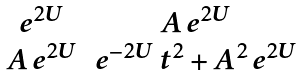<formula> <loc_0><loc_0><loc_500><loc_500>\begin{matrix} e ^ { 2 U } & A \, e ^ { 2 U } \\ A \, e ^ { 2 U } & e ^ { - 2 U } \, t ^ { 2 } + A ^ { 2 } \, e ^ { 2 U } \end{matrix}</formula> 